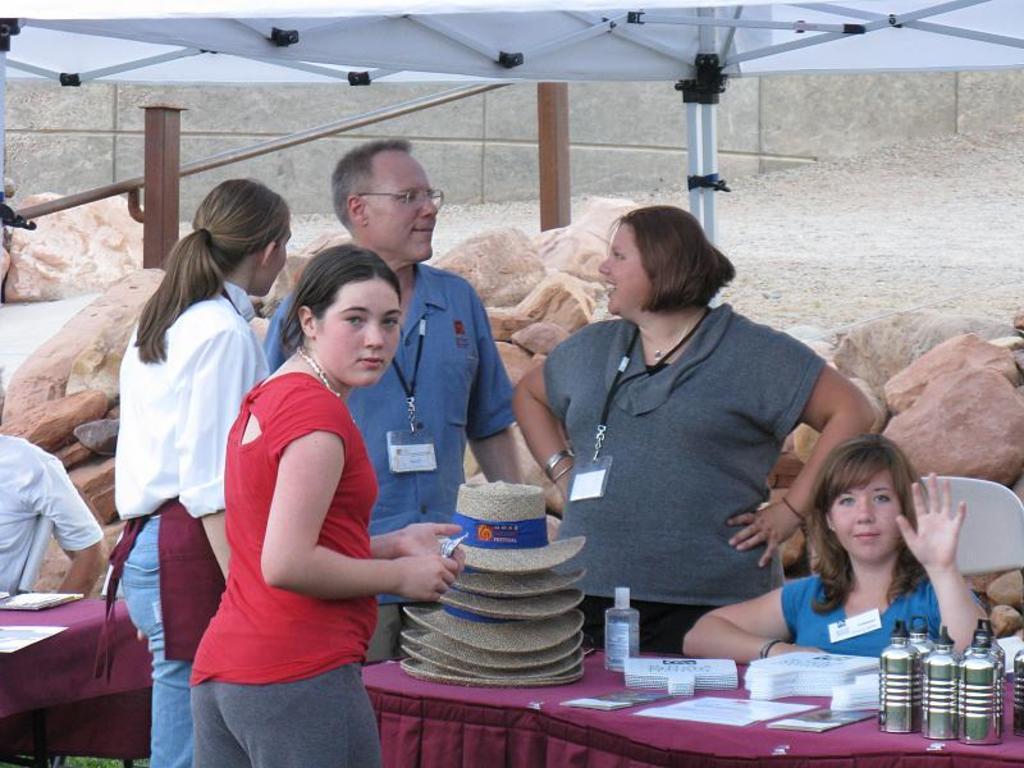Can you describe this image briefly? In this image i can see a group of people standing and sitting on a chair in front of a table. On the table I can see there are few objects on it. 